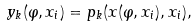Convert formula to latex. <formula><loc_0><loc_0><loc_500><loc_500>y _ { k } ( \varphi , x _ { i } ) = p _ { k } ( x ( \varphi , x _ { i } ) , x _ { i } ) ,</formula> 